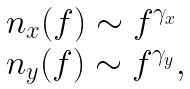<formula> <loc_0><loc_0><loc_500><loc_500>\begin{array} { l } n _ { x } ( f ) \sim f ^ { \gamma _ { x } } \\ n _ { y } ( f ) \sim f ^ { \gamma _ { y } } , \end{array}</formula> 